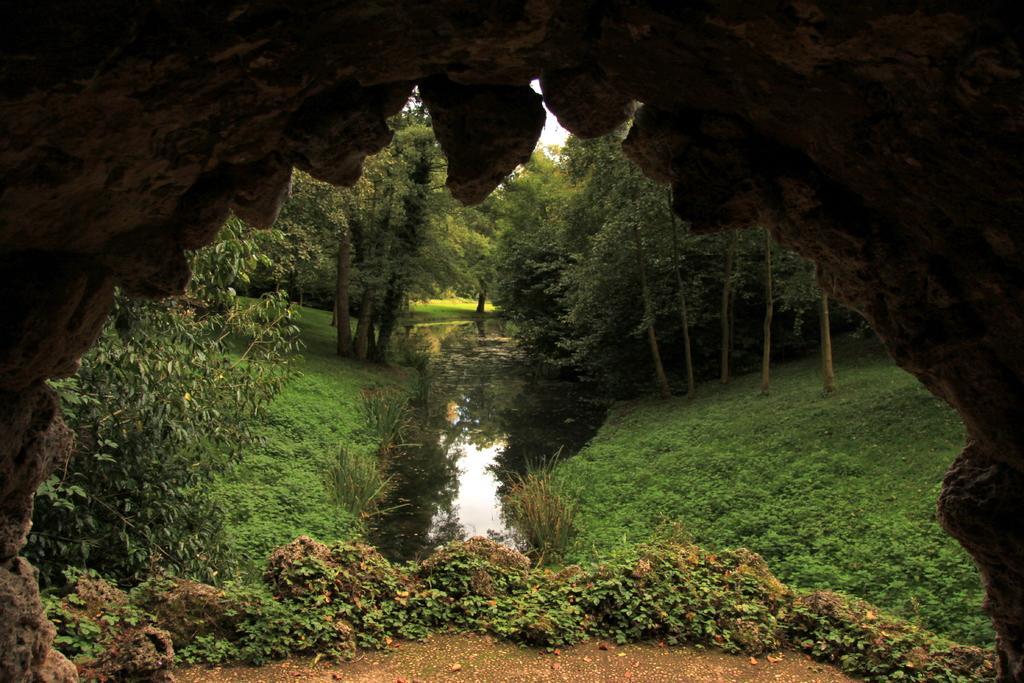Describe this image in one or two sentences. As we can see in the image there is grass, plants and trees. 